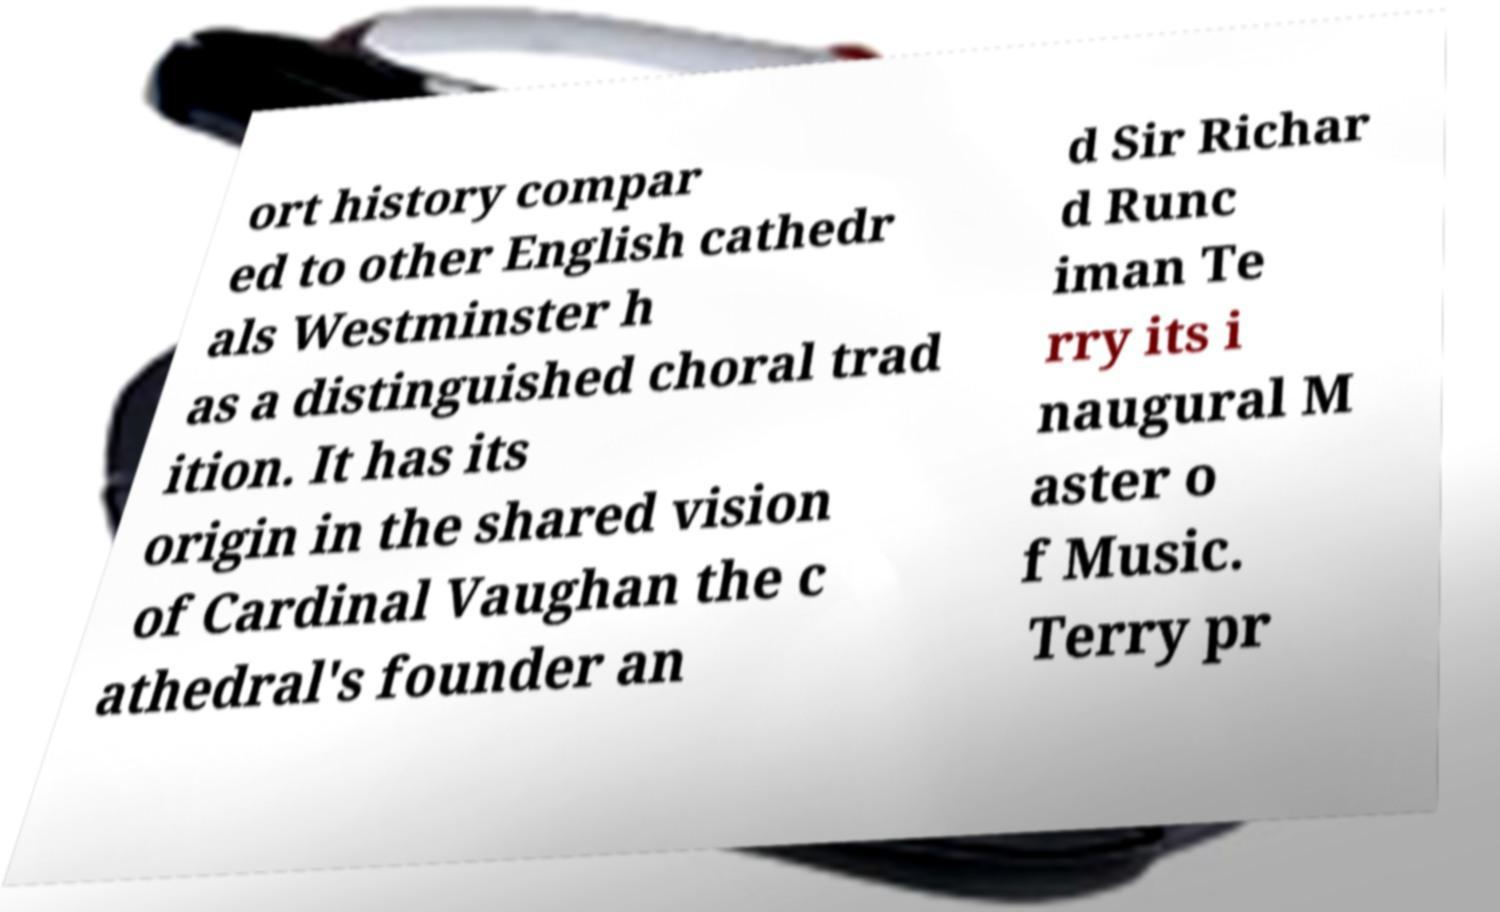For documentation purposes, I need the text within this image transcribed. Could you provide that? ort history compar ed to other English cathedr als Westminster h as a distinguished choral trad ition. It has its origin in the shared vision of Cardinal Vaughan the c athedral's founder an d Sir Richar d Runc iman Te rry its i naugural M aster o f Music. Terry pr 